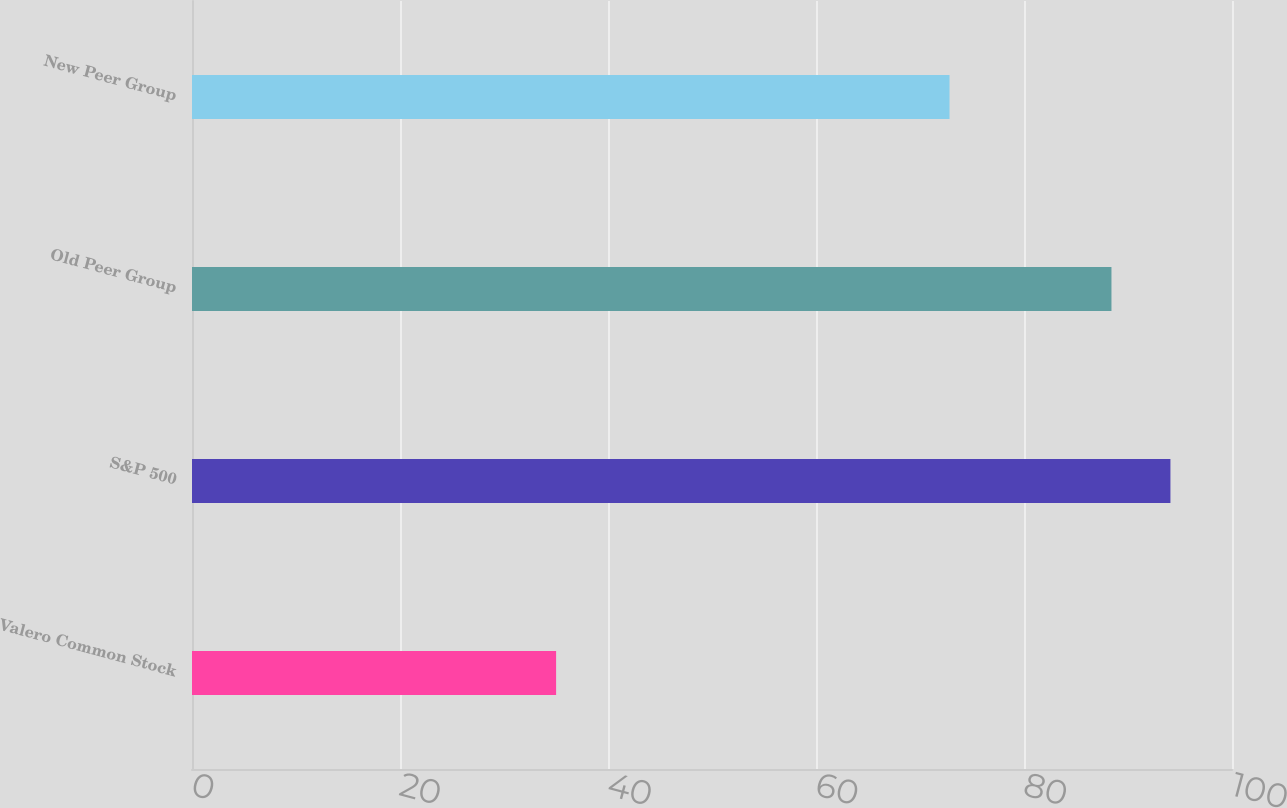Convert chart to OTSL. <chart><loc_0><loc_0><loc_500><loc_500><bar_chart><fcel>Valero Common Stock<fcel>S&P 500<fcel>Old Peer Group<fcel>New Peer Group<nl><fcel>35.01<fcel>94.08<fcel>88.41<fcel>72.84<nl></chart> 